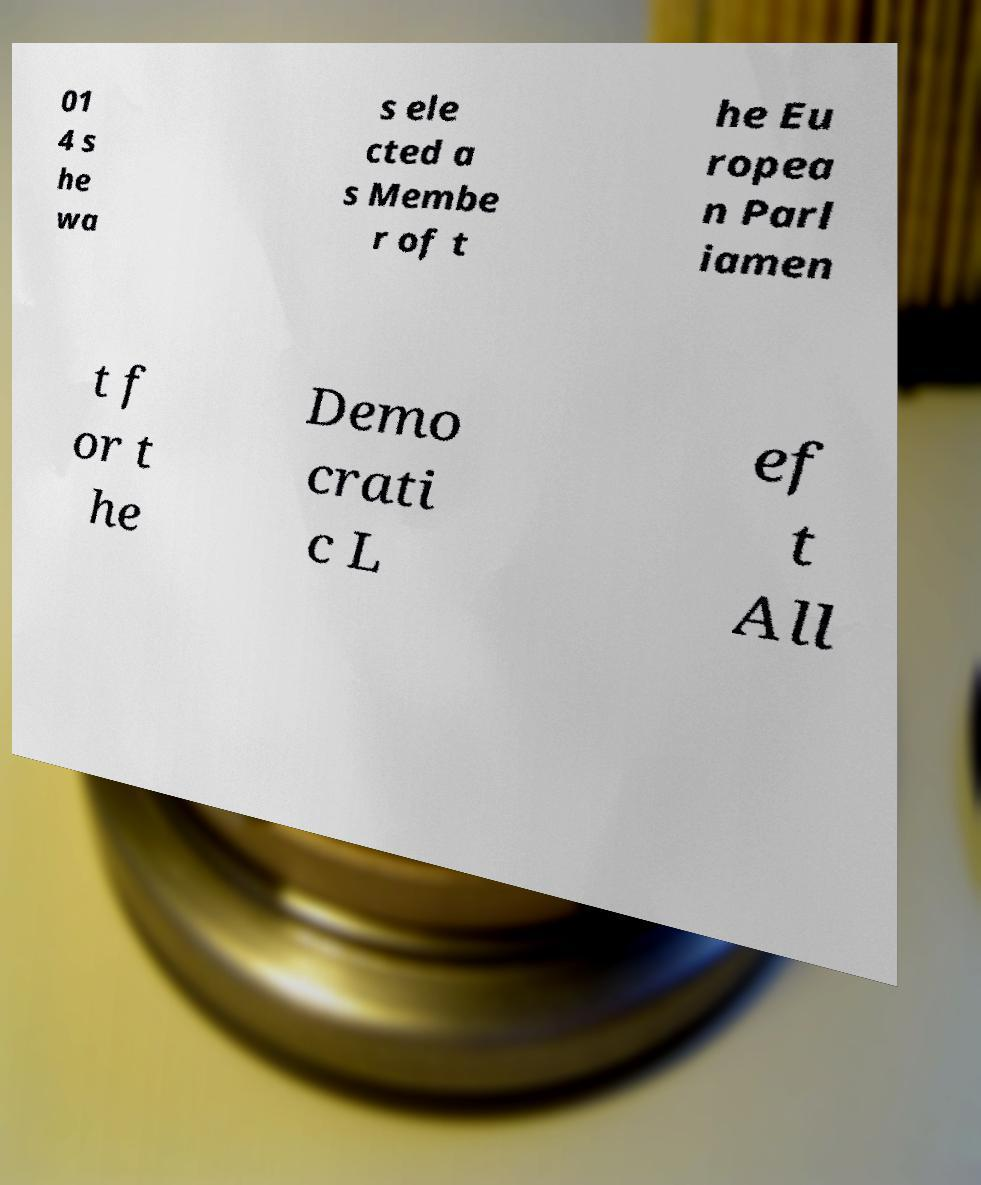Can you read and provide the text displayed in the image?This photo seems to have some interesting text. Can you extract and type it out for me? 01 4 s he wa s ele cted a s Membe r of t he Eu ropea n Parl iamen t f or t he Demo crati c L ef t All 